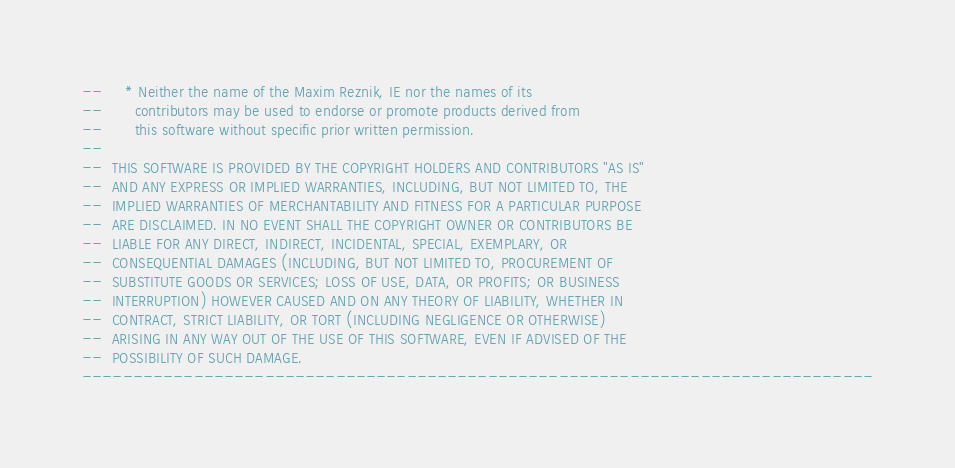Convert code to text. <code><loc_0><loc_0><loc_500><loc_500><_Ada_>--     * Neither the name of the Maxim Reznik, IE nor the names of its
--       contributors may be used to endorse or promote products derived from
--       this software without specific prior written permission.
--
--  THIS SOFTWARE IS PROVIDED BY THE COPYRIGHT HOLDERS AND CONTRIBUTORS "AS IS"
--  AND ANY EXPRESS OR IMPLIED WARRANTIES, INCLUDING, BUT NOT LIMITED TO, THE
--  IMPLIED WARRANTIES OF MERCHANTABILITY AND FITNESS FOR A PARTICULAR PURPOSE
--  ARE DISCLAIMED. IN NO EVENT SHALL THE COPYRIGHT OWNER OR CONTRIBUTORS BE
--  LIABLE FOR ANY DIRECT, INDIRECT, INCIDENTAL, SPECIAL, EXEMPLARY, OR
--  CONSEQUENTIAL DAMAGES (INCLUDING, BUT NOT LIMITED TO, PROCUREMENT OF
--  SUBSTITUTE GOODS OR SERVICES; LOSS OF USE, DATA, OR PROFITS; OR BUSINESS
--  INTERRUPTION) HOWEVER CAUSED AND ON ANY THEORY OF LIABILITY, WHETHER IN
--  CONTRACT, STRICT LIABILITY, OR TORT (INCLUDING NEGLIGENCE OR OTHERWISE)
--  ARISING IN ANY WAY OUT OF THE USE OF THIS SOFTWARE, EVEN IF ADVISED OF THE
--  POSSIBILITY OF SUCH DAMAGE.
------------------------------------------------------------------------------
</code> 